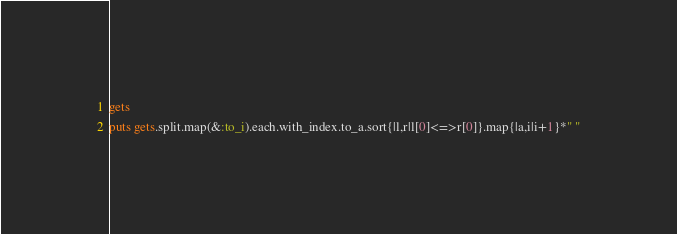<code> <loc_0><loc_0><loc_500><loc_500><_Ruby_>gets
puts gets.split.map(&:to_i).each.with_index.to_a.sort{|l,r|l[0]<=>r[0]}.map{|a,i|i+1}*" "</code> 